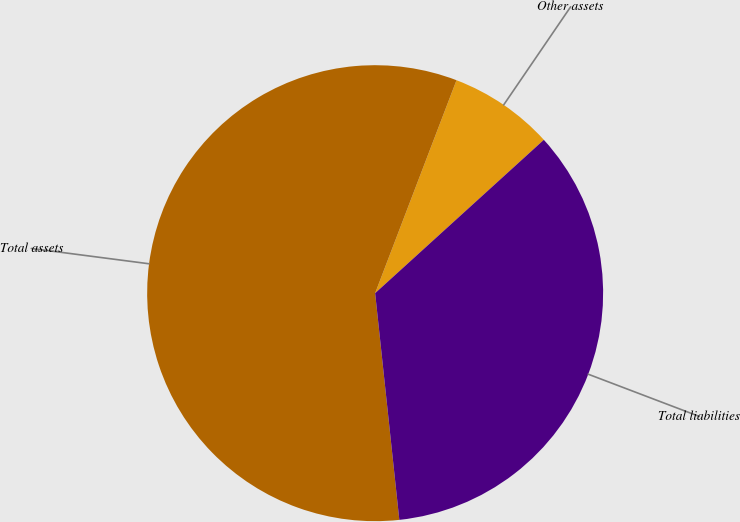Convert chart to OTSL. <chart><loc_0><loc_0><loc_500><loc_500><pie_chart><fcel>Other assets<fcel>Total assets<fcel>Total liabilities<nl><fcel>7.45%<fcel>57.5%<fcel>35.05%<nl></chart> 